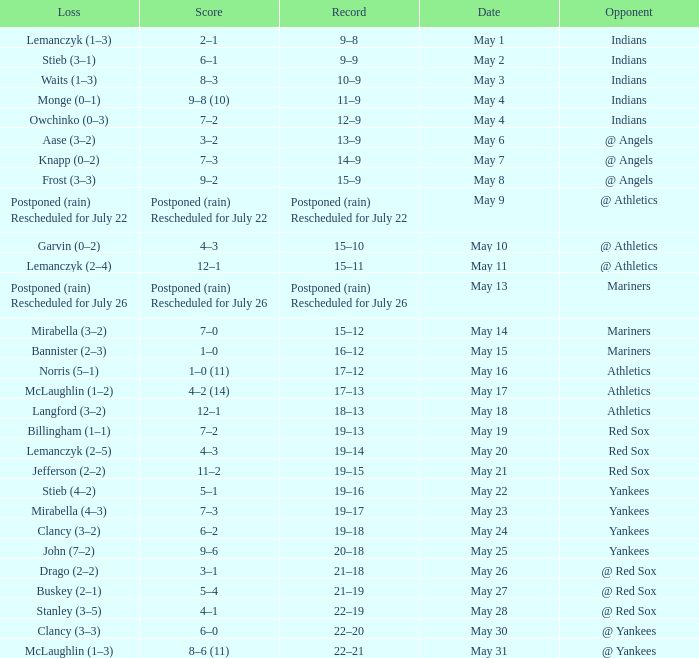Name the loss on may 22 Stieb (4–2). 